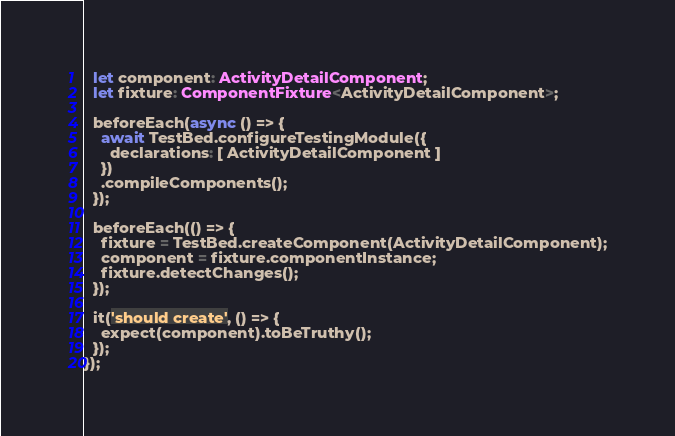<code> <loc_0><loc_0><loc_500><loc_500><_TypeScript_>  let component: ActivityDetailComponent;
  let fixture: ComponentFixture<ActivityDetailComponent>;

  beforeEach(async () => {
    await TestBed.configureTestingModule({
      declarations: [ ActivityDetailComponent ]
    })
    .compileComponents();
  });

  beforeEach(() => {
    fixture = TestBed.createComponent(ActivityDetailComponent);
    component = fixture.componentInstance;
    fixture.detectChanges();
  });

  it('should create', () => {
    expect(component).toBeTruthy();
  });
});
</code> 